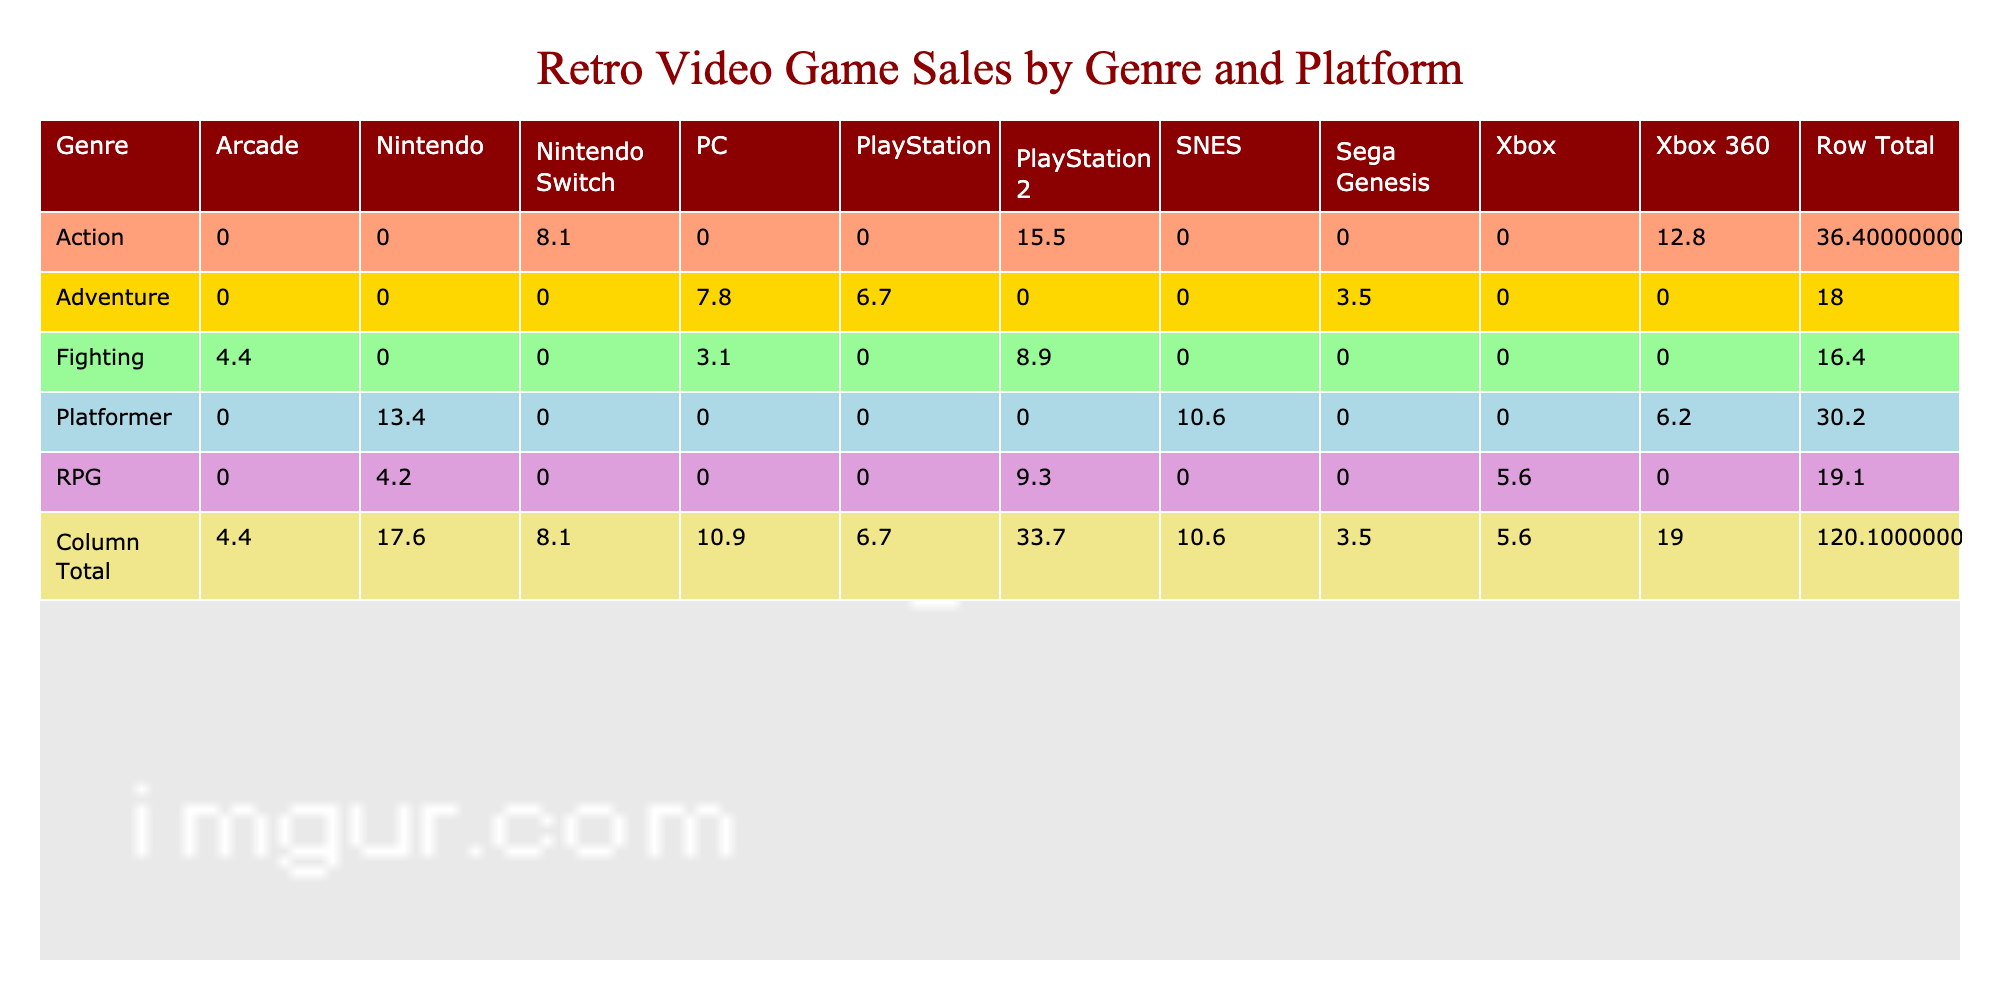What is the total sales for the Action genre? To find the total sales for the Action genre, we look at the Sales column under the Action row. The values for Action are 15.5 (PlayStation 2) + 12.8 (Xbox 360) + 8.1 (Nintendo Switch). Summing these gives us 15.5 + 12.8 + 8.1 = 36.4
Answer: 36.4 Which platform had the highest sales in the RPG genre? In the RPG genre, we compare the Sales values for each platform: 9.3 (PlayStation 2), 5.6 (Xbox), and 4.2 (Nintendo). The highest value is 9.3 from PlayStation 2.
Answer: PlayStation 2 Is the total sales of Platformer games higher than Fighting games? We first calculate the total sales for each genre. The Platformer genre has 13.4 (Nintendo) + 10.6 (SNES) + 6.2 (Xbox 360) = 30.2. The Fighting genre has 8.9 (PlayStation 2) + 4.4 (Arcade) + 3.1 (PC) = 16.4. Since 30.2 is greater than 16.4, the total sales of Platformer games is indeed higher.
Answer: Yes What is the average sales for the Adventure genre? In the Adventure genre, we have three platforms with sales: 6.7 (PlayStation) + 3.5 (Sega Genesis) + 7.8 (PC). Adding these gives 6.7 + 3.5 + 7.8 = 18. The number of platforms is 3, so to find the average, we divide the total sales by the number of platforms: 18 / 3 = 6.
Answer: 6 Which genre had the lowest total sales overall? To determine the lowest total sales, we need to sum the sales for all genres: Action (36.4), RPG (19.1), Adventure (17.0), Platformer (30.2), and Fighting (16.4). The totals are: Action (36.4), RPG (19.1), Adventure (17.0), Platformer (30.2), and Fighting (16.4). The lowest total is Fighting with 16.4.
Answer: Fighting 